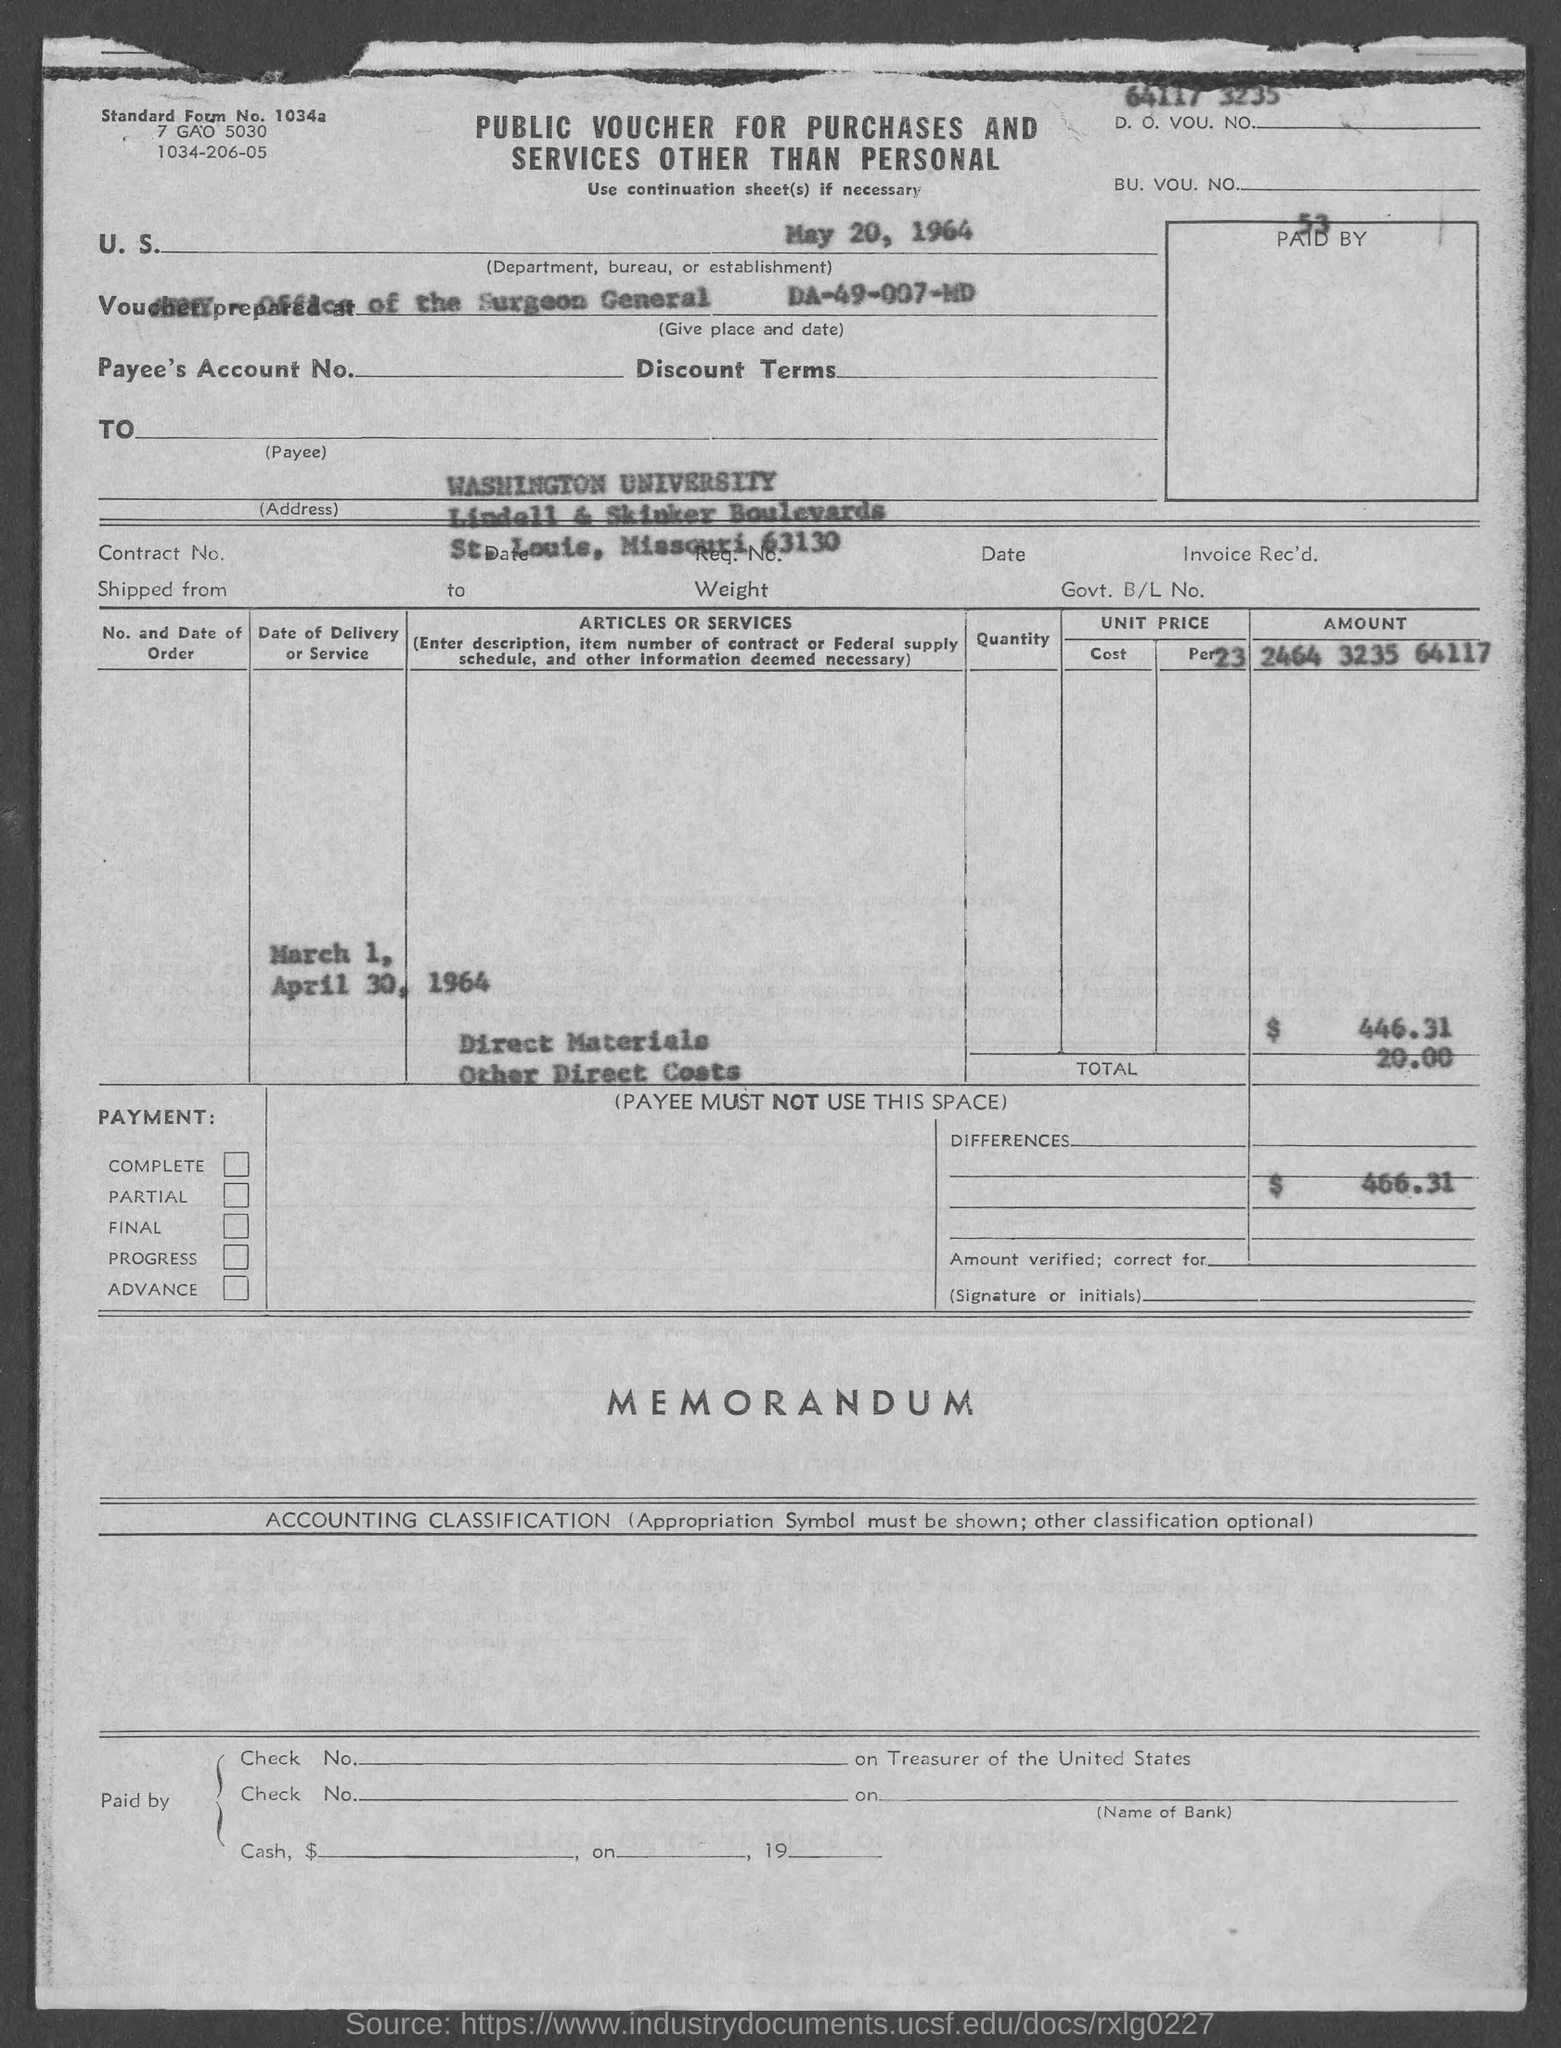Outline some significant characteristics in this image. What is the standard form number 1034a...?" is a question asking for information about a specific type or version of a document or record. 